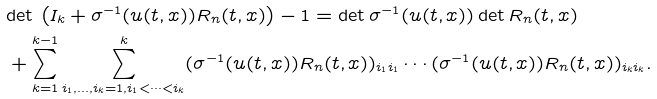Convert formula to latex. <formula><loc_0><loc_0><loc_500><loc_500>& \text {det} \, \left ( I _ { k } + \sigma ^ { - 1 } ( u ( t , x ) ) R _ { n } ( t , x ) \right ) - 1 = \text {det} \, \sigma ^ { - 1 } ( u ( t , x ) ) \, \text {det} \, R _ { n } ( t , x ) \\ & + \sum _ { k = 1 } ^ { k - 1 } \sum _ { i _ { 1 } , \dots , i _ { k } = 1 , i _ { 1 } < \cdots < i _ { k } } ^ { k } ( \sigma ^ { - 1 } ( u ( t , x ) ) R _ { n } ( t , x ) ) _ { i _ { 1 } i _ { 1 } } \cdots ( \sigma ^ { - 1 } ( u ( t , x ) ) R _ { n } ( t , x ) ) _ { i _ { k } i _ { k } } .</formula> 